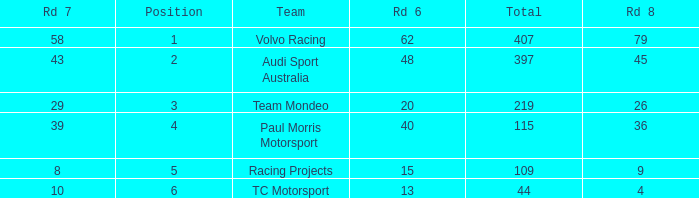What is the total sum of rd 7 values that are below 8? None. 